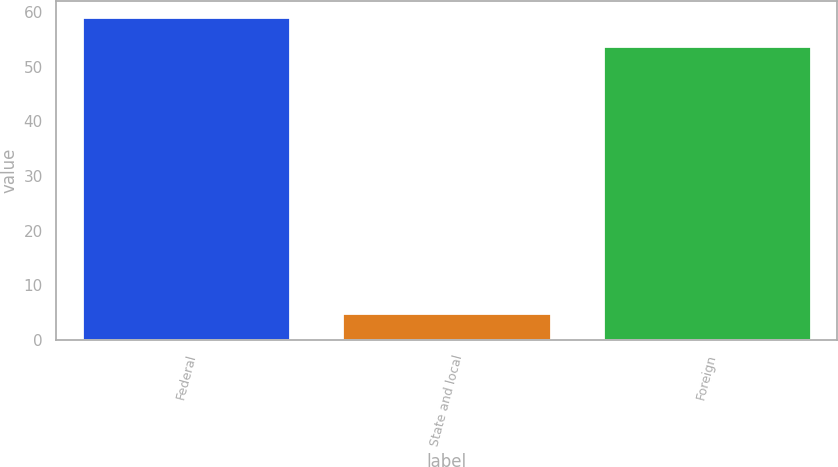<chart> <loc_0><loc_0><loc_500><loc_500><bar_chart><fcel>Federal<fcel>State and local<fcel>Foreign<nl><fcel>59.11<fcel>4.9<fcel>53.9<nl></chart> 